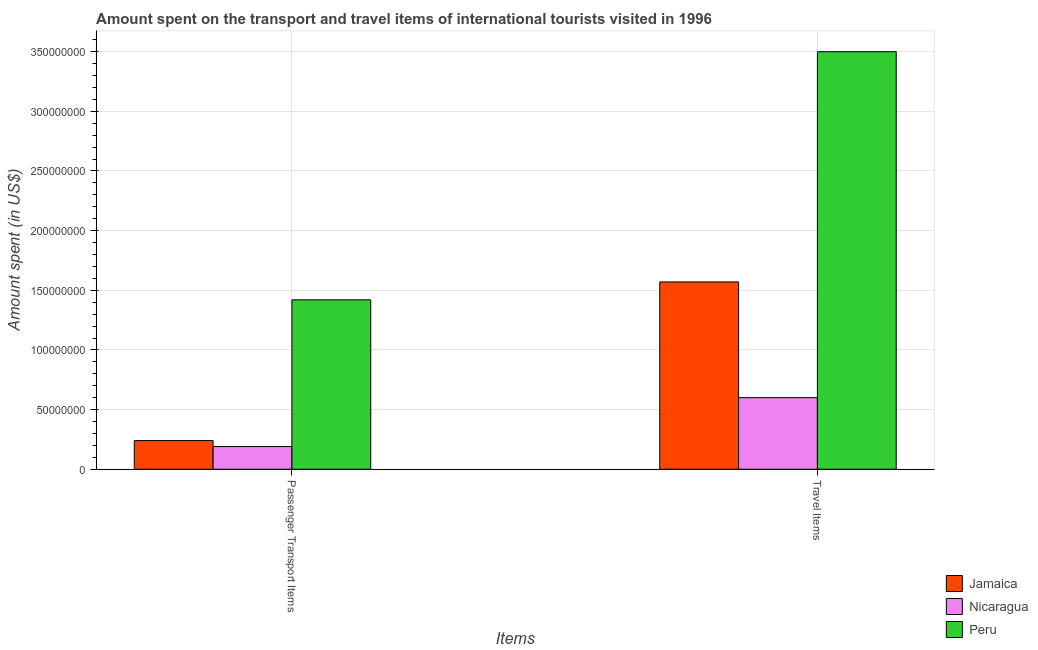Are the number of bars per tick equal to the number of legend labels?
Your response must be concise. Yes. Are the number of bars on each tick of the X-axis equal?
Provide a succinct answer. Yes. How many bars are there on the 1st tick from the left?
Ensure brevity in your answer.  3. What is the label of the 1st group of bars from the left?
Your response must be concise. Passenger Transport Items. What is the amount spent in travel items in Nicaragua?
Your response must be concise. 6.00e+07. Across all countries, what is the maximum amount spent in travel items?
Your answer should be compact. 3.50e+08. Across all countries, what is the minimum amount spent on passenger transport items?
Give a very brief answer. 1.90e+07. In which country was the amount spent on passenger transport items minimum?
Your answer should be compact. Nicaragua. What is the total amount spent on passenger transport items in the graph?
Your response must be concise. 1.85e+08. What is the difference between the amount spent in travel items in Nicaragua and that in Jamaica?
Your answer should be very brief. -9.70e+07. What is the difference between the amount spent in travel items in Jamaica and the amount spent on passenger transport items in Peru?
Your response must be concise. 1.50e+07. What is the average amount spent in travel items per country?
Ensure brevity in your answer.  1.89e+08. What is the difference between the amount spent on passenger transport items and amount spent in travel items in Jamaica?
Ensure brevity in your answer.  -1.33e+08. What is the ratio of the amount spent in travel items in Peru to that in Nicaragua?
Offer a very short reply. 5.83. Is the amount spent in travel items in Jamaica less than that in Nicaragua?
Give a very brief answer. No. What does the 1st bar from the left in Passenger Transport Items represents?
Your answer should be very brief. Jamaica. How many bars are there?
Provide a short and direct response. 6. What is the difference between two consecutive major ticks on the Y-axis?
Your answer should be compact. 5.00e+07. Are the values on the major ticks of Y-axis written in scientific E-notation?
Give a very brief answer. No. Where does the legend appear in the graph?
Offer a very short reply. Bottom right. How many legend labels are there?
Your answer should be very brief. 3. What is the title of the graph?
Provide a short and direct response. Amount spent on the transport and travel items of international tourists visited in 1996. Does "Middle income" appear as one of the legend labels in the graph?
Provide a short and direct response. No. What is the label or title of the X-axis?
Ensure brevity in your answer.  Items. What is the label or title of the Y-axis?
Offer a terse response. Amount spent (in US$). What is the Amount spent (in US$) of Jamaica in Passenger Transport Items?
Offer a terse response. 2.40e+07. What is the Amount spent (in US$) in Nicaragua in Passenger Transport Items?
Ensure brevity in your answer.  1.90e+07. What is the Amount spent (in US$) in Peru in Passenger Transport Items?
Ensure brevity in your answer.  1.42e+08. What is the Amount spent (in US$) of Jamaica in Travel Items?
Keep it short and to the point. 1.57e+08. What is the Amount spent (in US$) of Nicaragua in Travel Items?
Ensure brevity in your answer.  6.00e+07. What is the Amount spent (in US$) of Peru in Travel Items?
Offer a very short reply. 3.50e+08. Across all Items, what is the maximum Amount spent (in US$) in Jamaica?
Provide a short and direct response. 1.57e+08. Across all Items, what is the maximum Amount spent (in US$) of Nicaragua?
Provide a short and direct response. 6.00e+07. Across all Items, what is the maximum Amount spent (in US$) in Peru?
Provide a short and direct response. 3.50e+08. Across all Items, what is the minimum Amount spent (in US$) in Jamaica?
Keep it short and to the point. 2.40e+07. Across all Items, what is the minimum Amount spent (in US$) in Nicaragua?
Your answer should be very brief. 1.90e+07. Across all Items, what is the minimum Amount spent (in US$) in Peru?
Ensure brevity in your answer.  1.42e+08. What is the total Amount spent (in US$) of Jamaica in the graph?
Provide a short and direct response. 1.81e+08. What is the total Amount spent (in US$) in Nicaragua in the graph?
Your answer should be very brief. 7.90e+07. What is the total Amount spent (in US$) of Peru in the graph?
Offer a terse response. 4.92e+08. What is the difference between the Amount spent (in US$) of Jamaica in Passenger Transport Items and that in Travel Items?
Your response must be concise. -1.33e+08. What is the difference between the Amount spent (in US$) of Nicaragua in Passenger Transport Items and that in Travel Items?
Ensure brevity in your answer.  -4.10e+07. What is the difference between the Amount spent (in US$) of Peru in Passenger Transport Items and that in Travel Items?
Your response must be concise. -2.08e+08. What is the difference between the Amount spent (in US$) in Jamaica in Passenger Transport Items and the Amount spent (in US$) in Nicaragua in Travel Items?
Offer a terse response. -3.60e+07. What is the difference between the Amount spent (in US$) of Jamaica in Passenger Transport Items and the Amount spent (in US$) of Peru in Travel Items?
Give a very brief answer. -3.26e+08. What is the difference between the Amount spent (in US$) in Nicaragua in Passenger Transport Items and the Amount spent (in US$) in Peru in Travel Items?
Your answer should be very brief. -3.31e+08. What is the average Amount spent (in US$) of Jamaica per Items?
Your response must be concise. 9.05e+07. What is the average Amount spent (in US$) in Nicaragua per Items?
Your answer should be compact. 3.95e+07. What is the average Amount spent (in US$) in Peru per Items?
Your answer should be compact. 2.46e+08. What is the difference between the Amount spent (in US$) of Jamaica and Amount spent (in US$) of Nicaragua in Passenger Transport Items?
Offer a terse response. 5.00e+06. What is the difference between the Amount spent (in US$) in Jamaica and Amount spent (in US$) in Peru in Passenger Transport Items?
Your answer should be very brief. -1.18e+08. What is the difference between the Amount spent (in US$) of Nicaragua and Amount spent (in US$) of Peru in Passenger Transport Items?
Your response must be concise. -1.23e+08. What is the difference between the Amount spent (in US$) of Jamaica and Amount spent (in US$) of Nicaragua in Travel Items?
Keep it short and to the point. 9.70e+07. What is the difference between the Amount spent (in US$) of Jamaica and Amount spent (in US$) of Peru in Travel Items?
Give a very brief answer. -1.93e+08. What is the difference between the Amount spent (in US$) of Nicaragua and Amount spent (in US$) of Peru in Travel Items?
Make the answer very short. -2.90e+08. What is the ratio of the Amount spent (in US$) of Jamaica in Passenger Transport Items to that in Travel Items?
Your answer should be compact. 0.15. What is the ratio of the Amount spent (in US$) of Nicaragua in Passenger Transport Items to that in Travel Items?
Provide a succinct answer. 0.32. What is the ratio of the Amount spent (in US$) in Peru in Passenger Transport Items to that in Travel Items?
Ensure brevity in your answer.  0.41. What is the difference between the highest and the second highest Amount spent (in US$) of Jamaica?
Provide a short and direct response. 1.33e+08. What is the difference between the highest and the second highest Amount spent (in US$) of Nicaragua?
Your answer should be very brief. 4.10e+07. What is the difference between the highest and the second highest Amount spent (in US$) of Peru?
Provide a short and direct response. 2.08e+08. What is the difference between the highest and the lowest Amount spent (in US$) of Jamaica?
Ensure brevity in your answer.  1.33e+08. What is the difference between the highest and the lowest Amount spent (in US$) of Nicaragua?
Provide a short and direct response. 4.10e+07. What is the difference between the highest and the lowest Amount spent (in US$) of Peru?
Your answer should be compact. 2.08e+08. 